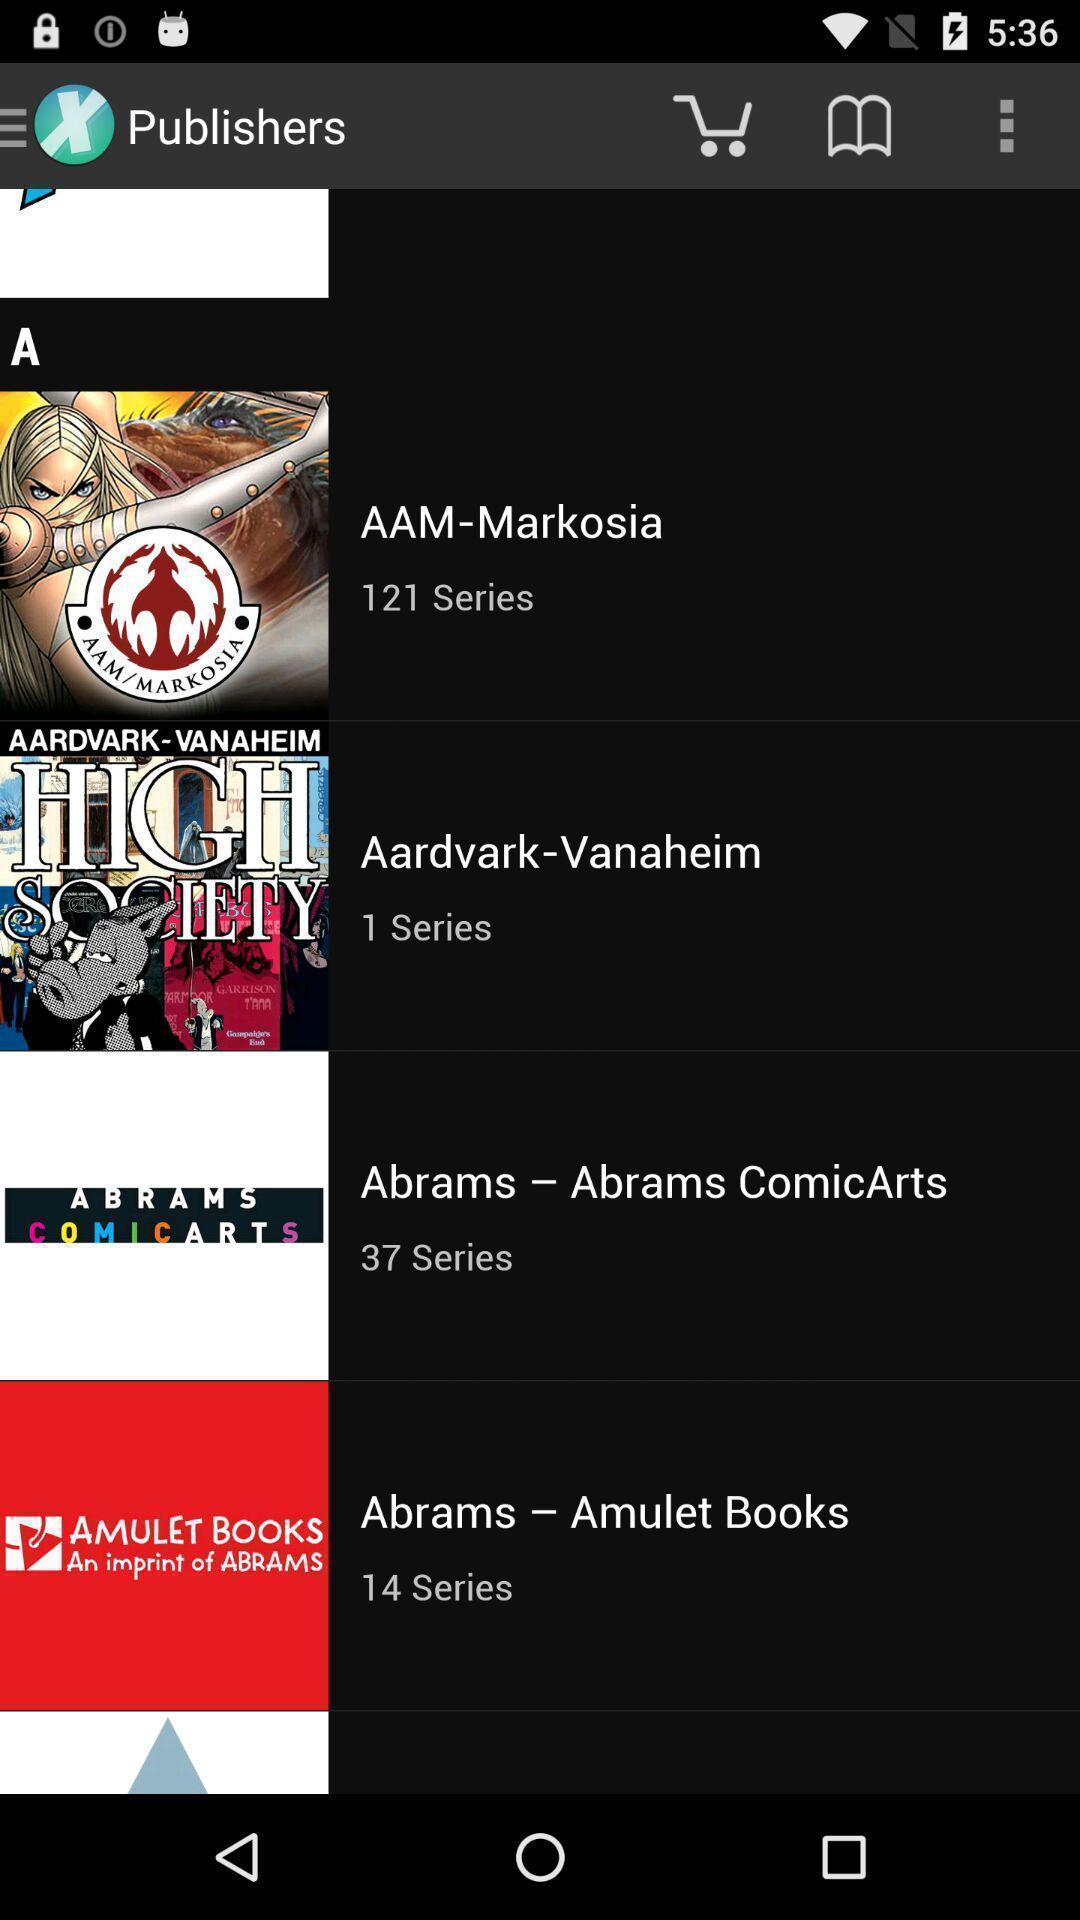Describe the visual elements of this screenshot. Screen displaying published books on a device. 